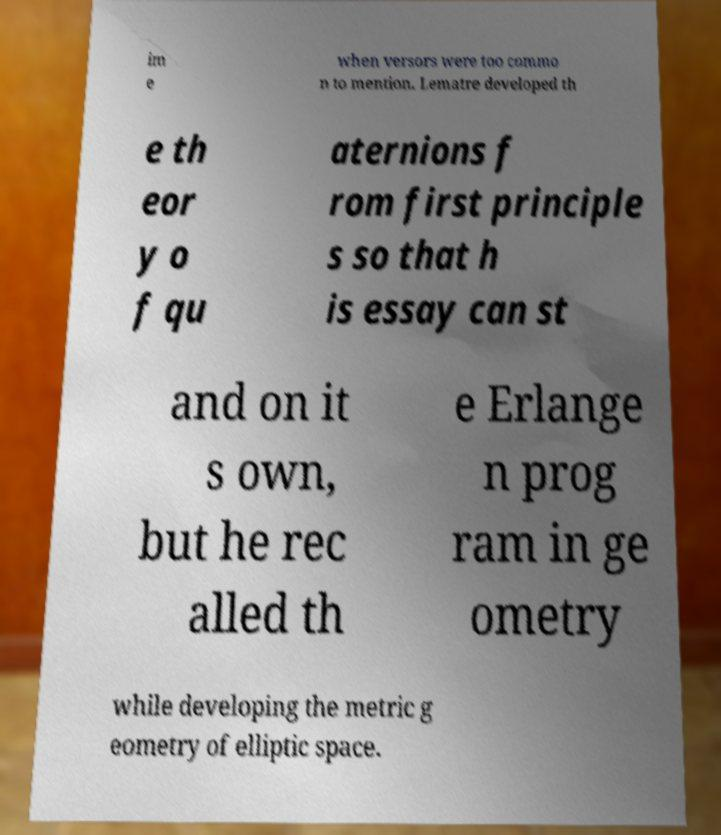Could you assist in decoding the text presented in this image and type it out clearly? im e when versors were too commo n to mention. Lematre developed th e th eor y o f qu aternions f rom first principle s so that h is essay can st and on it s own, but he rec alled th e Erlange n prog ram in ge ometry while developing the metric g eometry of elliptic space. 